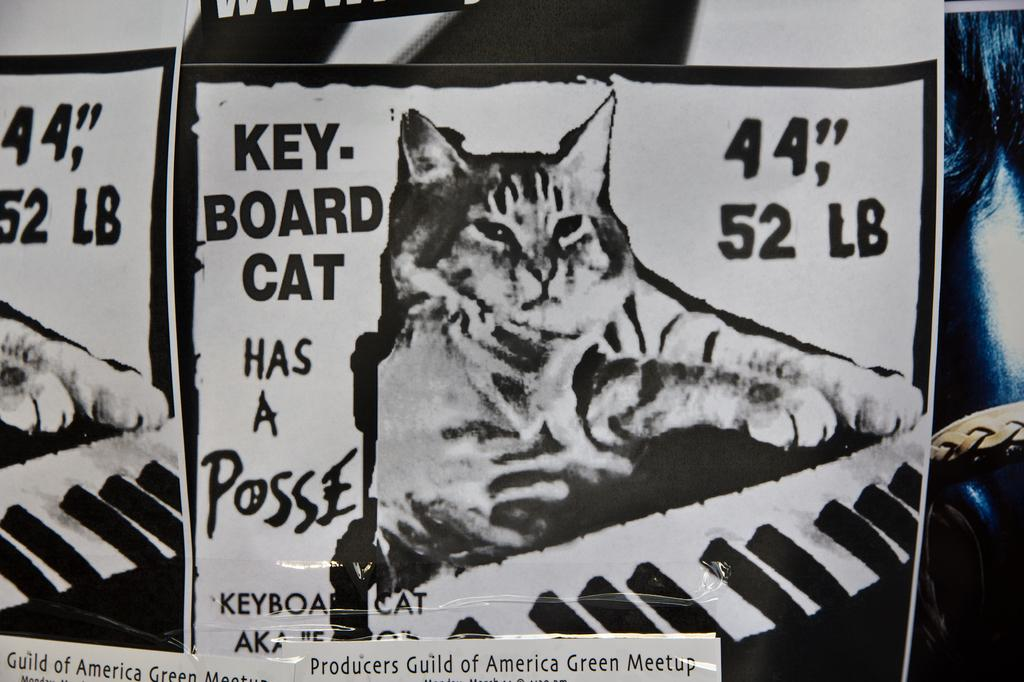What type of items can be seen on the walls in the image? There are posters in the image. What subjects are depicted on the posters? The posters depict cats and keyboards. Are there any other items visible in the image besides the posters? Yes, there are papers and a belt visible in the image. What can be found on the posters besides images? There is text on the posters. What can be seen in the background of the image? There are objects visible in the background of the image. How many visitors can be seen interacting with the robin in the image? There are no visitors or robins present in the image; it only features posters, papers, a belt, and objects in the background. 